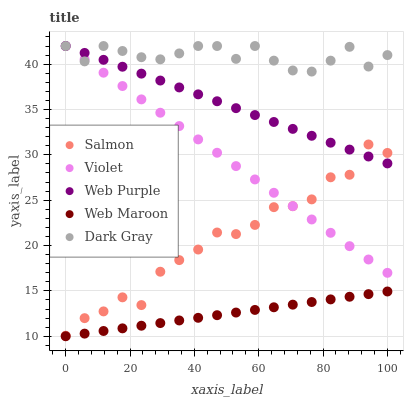Does Web Maroon have the minimum area under the curve?
Answer yes or no. Yes. Does Dark Gray have the maximum area under the curve?
Answer yes or no. Yes. Does Web Purple have the minimum area under the curve?
Answer yes or no. No. Does Web Purple have the maximum area under the curve?
Answer yes or no. No. Is Violet the smoothest?
Answer yes or no. Yes. Is Salmon the roughest?
Answer yes or no. Yes. Is Web Maroon the smoothest?
Answer yes or no. No. Is Web Maroon the roughest?
Answer yes or no. No. Does Web Maroon have the lowest value?
Answer yes or no. Yes. Does Web Purple have the lowest value?
Answer yes or no. No. Does Violet have the highest value?
Answer yes or no. Yes. Does Web Maroon have the highest value?
Answer yes or no. No. Is Web Maroon less than Dark Gray?
Answer yes or no. Yes. Is Salmon greater than Web Maroon?
Answer yes or no. Yes. Does Violet intersect Dark Gray?
Answer yes or no. Yes. Is Violet less than Dark Gray?
Answer yes or no. No. Is Violet greater than Dark Gray?
Answer yes or no. No. Does Web Maroon intersect Dark Gray?
Answer yes or no. No. 